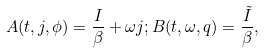<formula> <loc_0><loc_0><loc_500><loc_500>A ( t , j , \phi ) = \frac { I } { \beta } + { \omega } j ; B ( t , \omega , q ) = \frac { \tilde { I } } { \beta } ,</formula> 